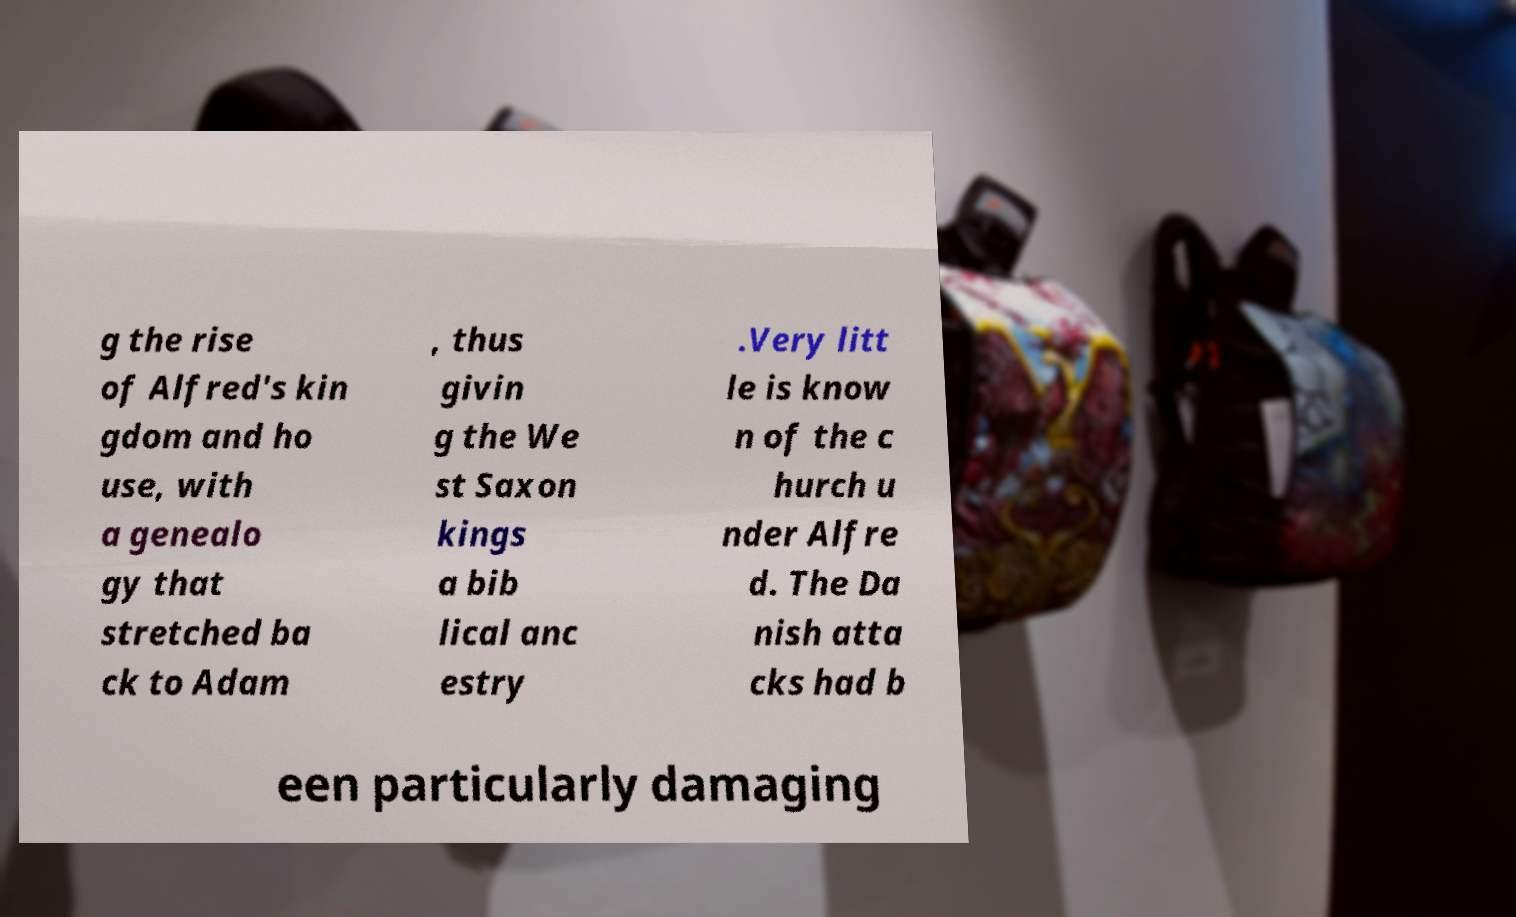For documentation purposes, I need the text within this image transcribed. Could you provide that? g the rise of Alfred's kin gdom and ho use, with a genealo gy that stretched ba ck to Adam , thus givin g the We st Saxon kings a bib lical anc estry .Very litt le is know n of the c hurch u nder Alfre d. The Da nish atta cks had b een particularly damaging 